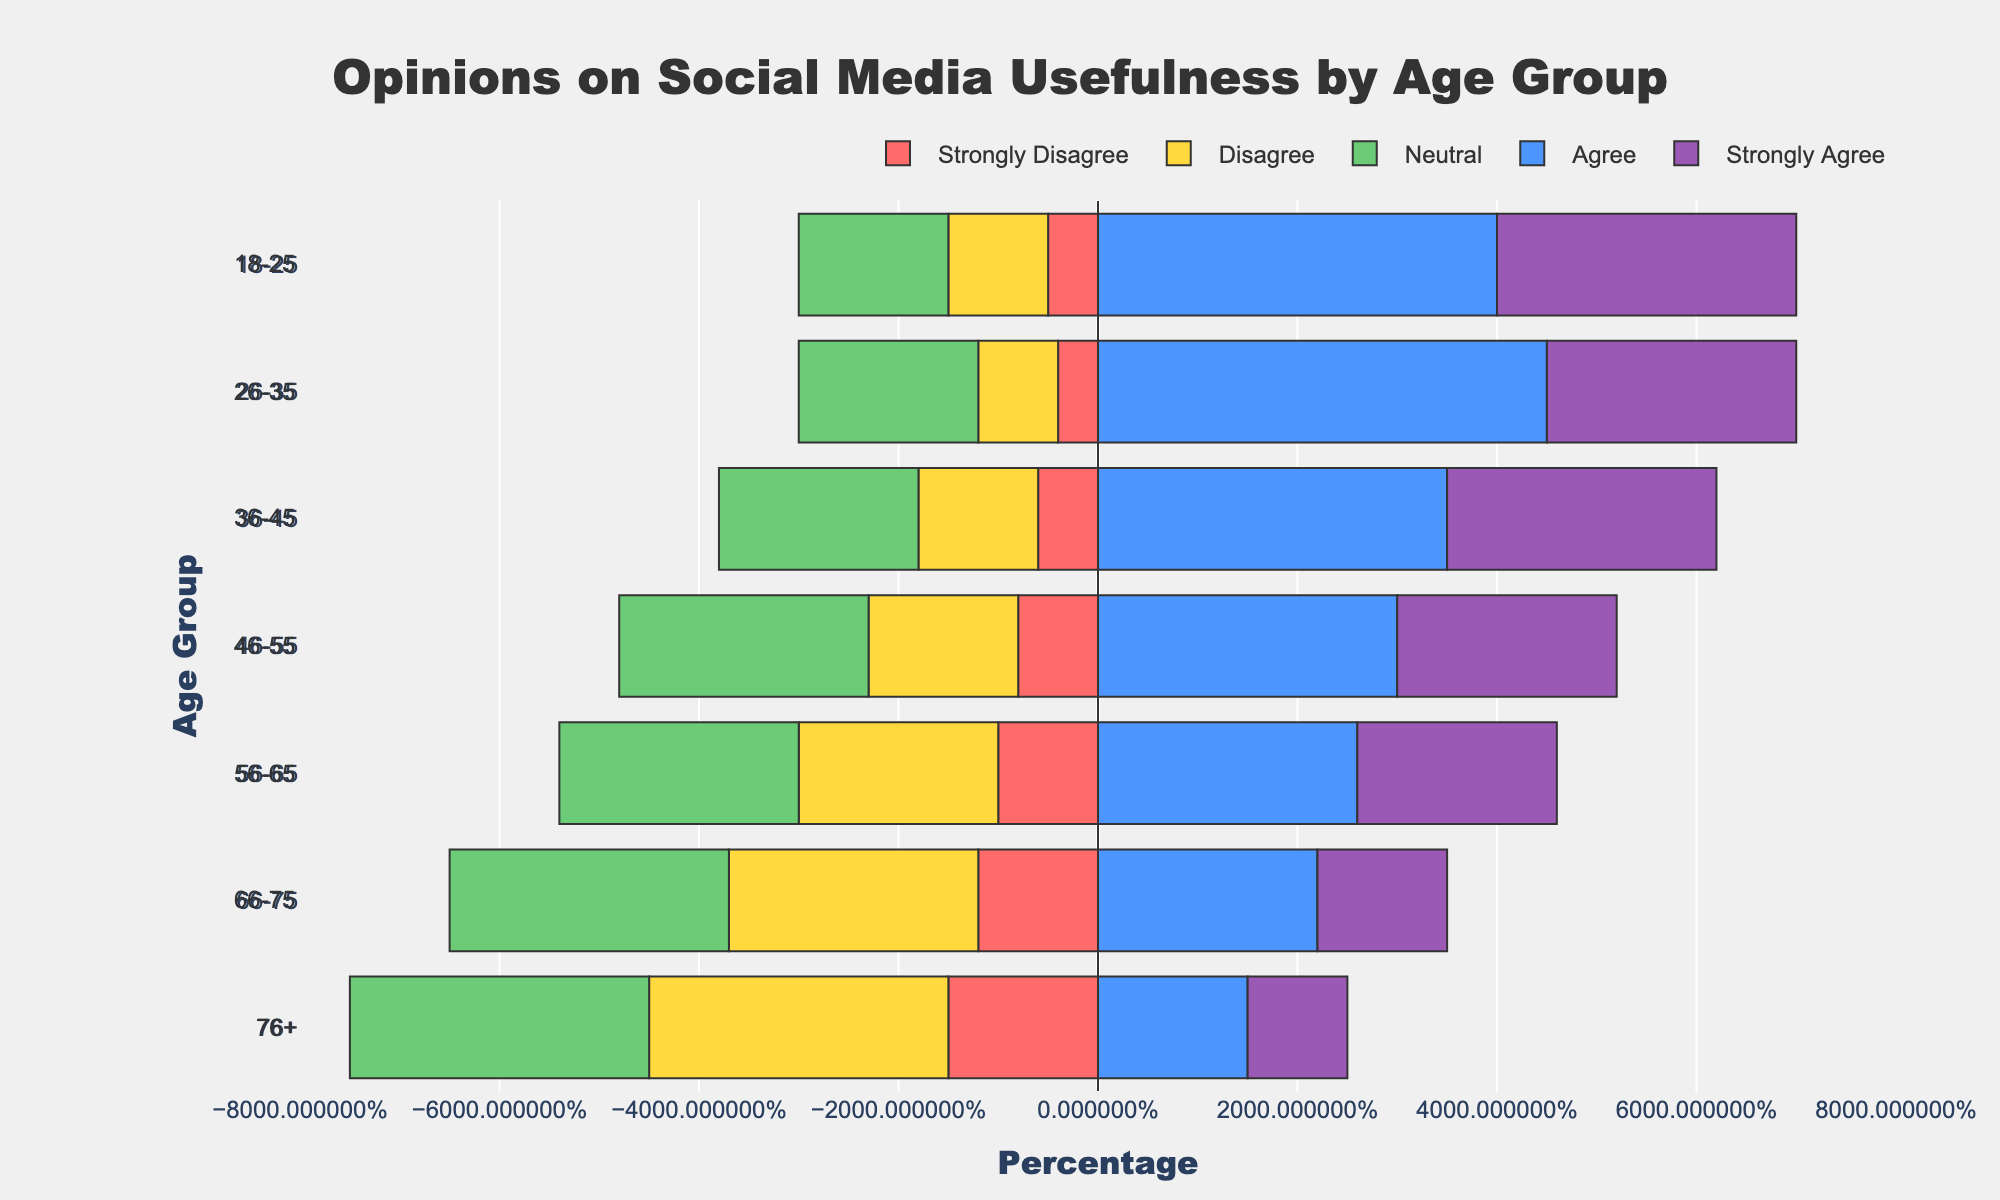What age group has the highest percentage of people who Strongly Agree with the usefulness of social media for staying connected? Looking at the "Strongly Agree" section (purple) of the bars, the 18-25 age group has the longest bar, indicating the highest percentage.
Answer: 18-25 Which age group has the highest combined percentage of Agree and Strongly Agree? Add the "Agree" and "Strongly Agree" percentages for each age group and compare. 18-25 has 40 + 30 = 70, 26-35 has 45 + 25 = 70, 36-45 has 35 + 27 = 62, and so on. The 18-25 and 26-35 age groups both have the highest combined percentage of 70.
Answer: 18-25 and 26-35 What is the difference in the percentage of people who Strongly Disagree between the 18-25 and 76+ age groups? Subtract the "Strongly Disagree" percentage for 18-25 (5) from the "Strongly Disagree" percentage for 76+ (15). The difference is 15 - 5 = 10.
Answer: 10 Which age group has the highest Neutral response regarding social media usefulness? Look at the "Neutral" section (yellow) of the bars. The 76+ age group has the longest bar, indicating the highest percentage of Neutral responses.
Answer: 76+ Across all age groups, which response (Strongly Disagree, Disagree, Neutral, Agree, Strongly Agree) has the most uniform distribution? Visually evaluate the lengths of the color segments across all age groups. "Neutral" (yellow) appears to be the most uniformly distributed since it has similar lengths in each age group.
Answer: Neutral What is the sum of the percentages for Strongly Agree and Strongly Disagree in the 56-65 age group? Add the "Strongly Agree" (20) and "Strongly Disagree" (10) percentages for the 56-65 age group. The sum is 20 + 10 = 30.
Answer: 30 Which age group has the lowest percentage of people who Disagree? Look at the "Disagree" section (orange) of the bars. The 18-25 age group has the shortest bar, indicating the lowest percentage.
Answer: 18-25 By how much does the percentage of people who Agree in the 26-35 age group differ from the percentage in the 76+ age group? Subtract the "Agree" percentage for 76+ (15) from the "Agree" percentage for 26-35 (45). The difference is 45 - 15 = 30.
Answer: 30 What is the combined percentage of Neutral and Disagree opinions in the 36-45 age group? Add the "Neutral" (20) and "Disagree" (12) percentages for the 36-45 age group. The combined percentage is 20 + 12 = 32.
Answer: 32 How does the percentage of people who Agree in the 66-75 age group compare to that in the 46-55 age group? Compare the "Agree" percentages between the two age groups. The 66-75 age group has 22, while the 46-55 age group has 30. So, the 66-75 age group has a lower percentage than the 46-55 age group.
Answer: Lower 